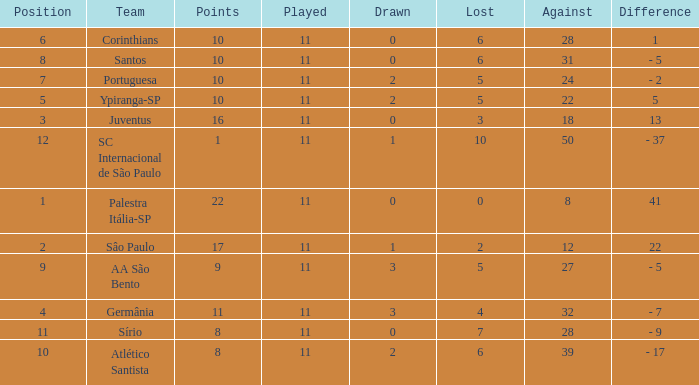What was the total number of Points when the value Difference was 13, and when the value Lost was greater than 3? None. 